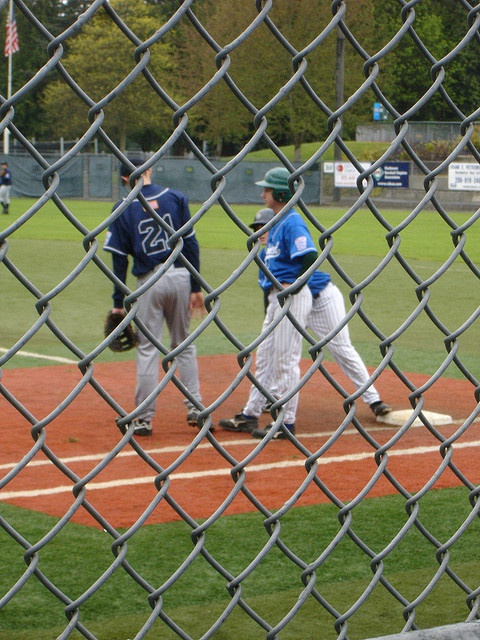Describe the objects in this image and their specific colors. I can see people in gray, darkgray, black, and navy tones, people in gray, darkgray, lightgray, and black tones, people in gray, lavender, darkgray, and tan tones, baseball glove in gray, black, and darkgreen tones, and people in gray, darkgray, black, and navy tones in this image. 